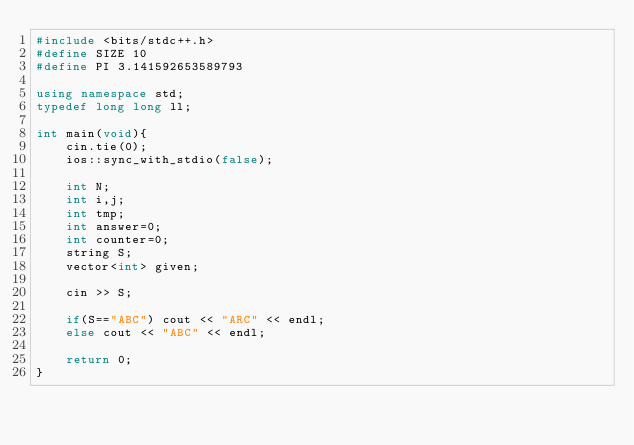<code> <loc_0><loc_0><loc_500><loc_500><_C++_>#include <bits/stdc++.h>
#define SIZE 10
#define PI 3.141592653589793

using namespace std;
typedef long long ll;

int main(void){
	cin.tie(0);
	ios::sync_with_stdio(false);

	int N;
	int i,j;
	int tmp;
	int answer=0;
	int counter=0;
	string S;
	vector<int> given;

	cin >> S;

	if(S=="ABC") cout << "ARC" << endl;
	else cout << "ABC" << endl;

	return 0;
}

</code> 